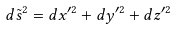Convert formula to latex. <formula><loc_0><loc_0><loc_500><loc_500>d { \tilde { s } } ^ { 2 } = d x ^ { \prime 2 } + d y ^ { \prime 2 } + d z ^ { \prime 2 }</formula> 